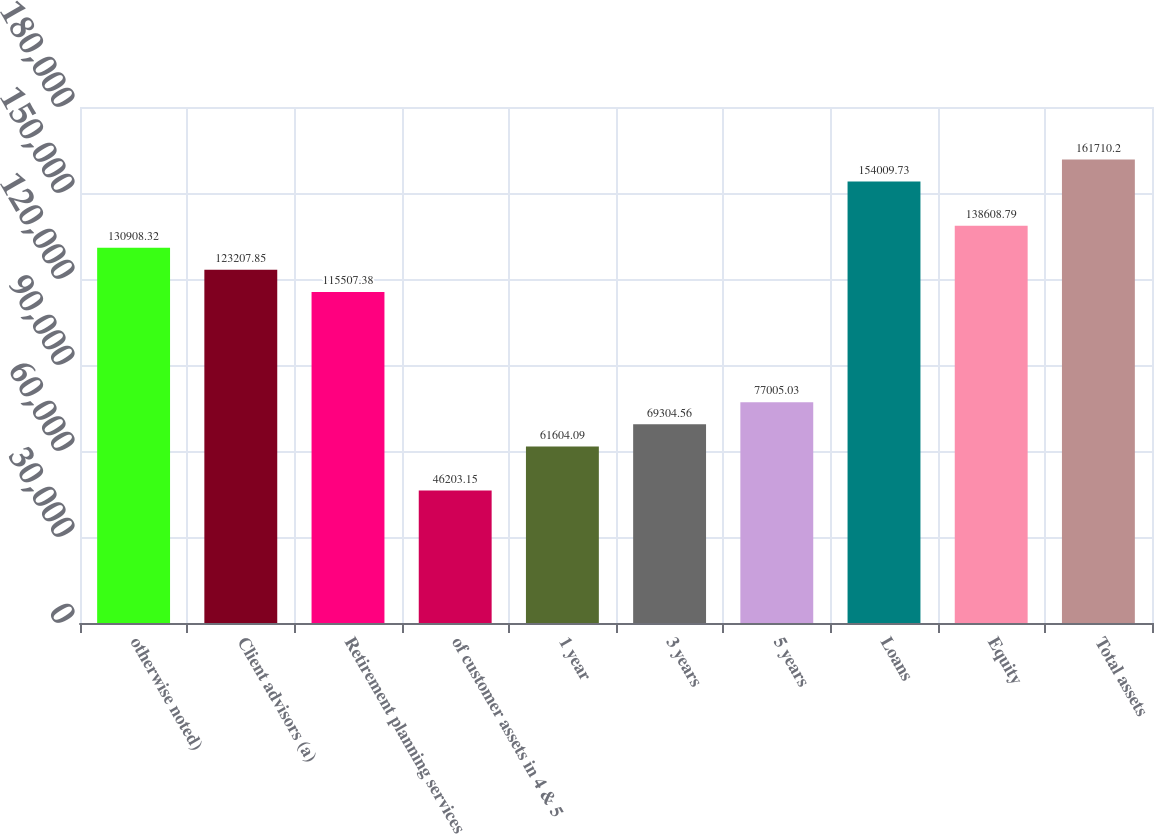Convert chart. <chart><loc_0><loc_0><loc_500><loc_500><bar_chart><fcel>otherwise noted)<fcel>Client advisors (a)<fcel>Retirement planning services<fcel>of customer assets in 4 & 5<fcel>1 year<fcel>3 years<fcel>5 years<fcel>Loans<fcel>Equity<fcel>Total assets<nl><fcel>130908<fcel>123208<fcel>115507<fcel>46203.2<fcel>61604.1<fcel>69304.6<fcel>77005<fcel>154010<fcel>138609<fcel>161710<nl></chart> 